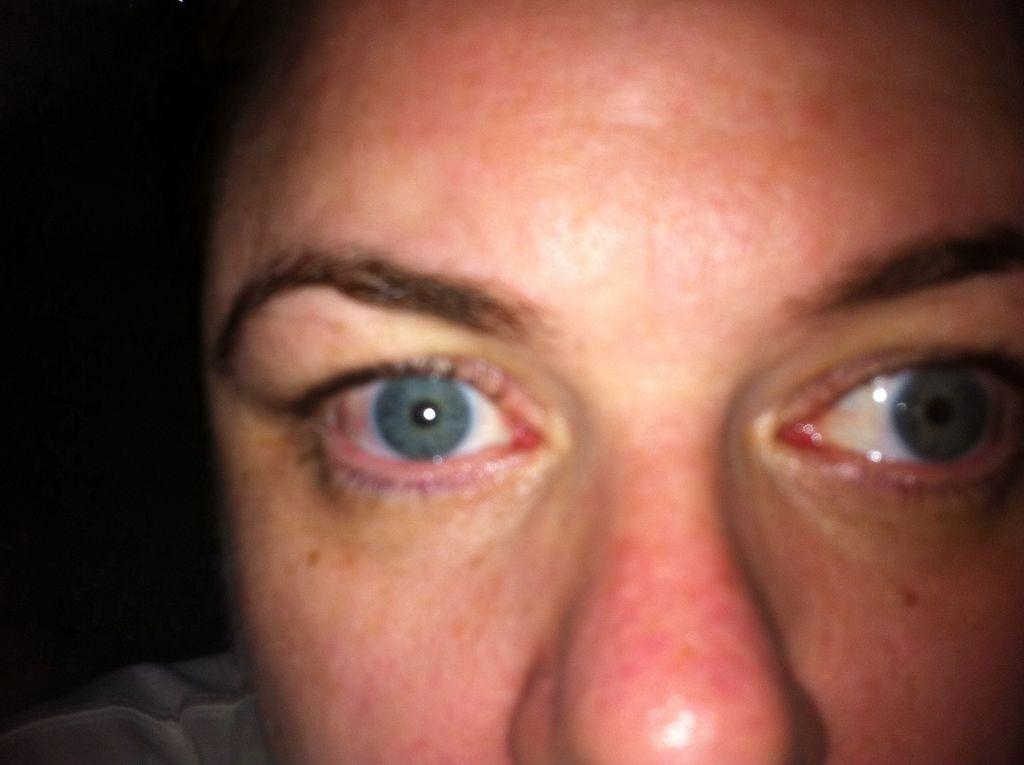Can you describe this image briefly? In this image I can see the person's face and I can see the dark background. 